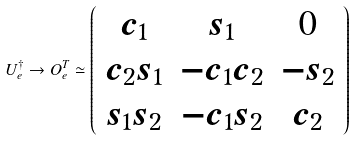Convert formula to latex. <formula><loc_0><loc_0><loc_500><loc_500>U _ { e } ^ { \dagger } \rightarrow O _ { e } ^ { T } \simeq \left ( \begin{array} { c c c } c _ { 1 } & s _ { 1 } & 0 \\ c _ { 2 } s _ { 1 } & - c _ { 1 } c _ { 2 } & - s _ { 2 } \\ s _ { 1 } s _ { 2 } & - c _ { 1 } s _ { 2 } & c _ { 2 } \\ \end{array} \right )</formula> 